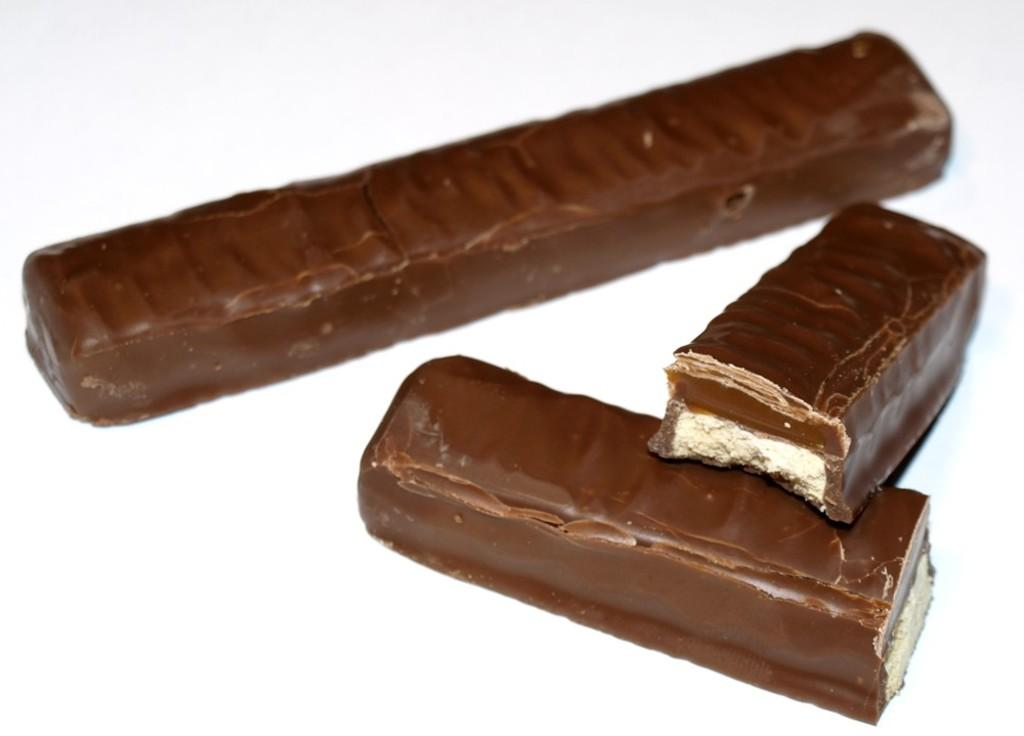What type of food is present in the image? There are chocolate bars in the image. Where are the chocolate bars located in the image? The chocolate bars are in the middle of the image. What type of shoe is visible in the image? There is no shoe present in the image; it only features chocolate bars. How much debt is associated with the chocolate bars in the image? There is no mention of debt in the image, as it only contains chocolate bars. 